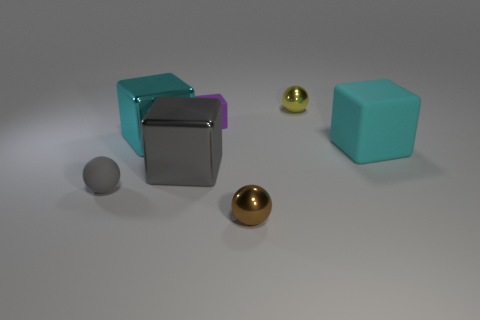Subtract all big cyan metal blocks. How many blocks are left? 3 Subtract all gray spheres. How many spheres are left? 2 Add 2 cyan blocks. How many objects exist? 9 Subtract all balls. How many objects are left? 4 Subtract 1 blocks. How many blocks are left? 3 Subtract all gray cubes. Subtract all yellow balls. How many cubes are left? 3 Subtract all brown cylinders. How many yellow spheres are left? 1 Subtract all small green blocks. Subtract all shiny cubes. How many objects are left? 5 Add 1 small yellow things. How many small yellow things are left? 2 Add 1 large purple shiny objects. How many large purple shiny objects exist? 1 